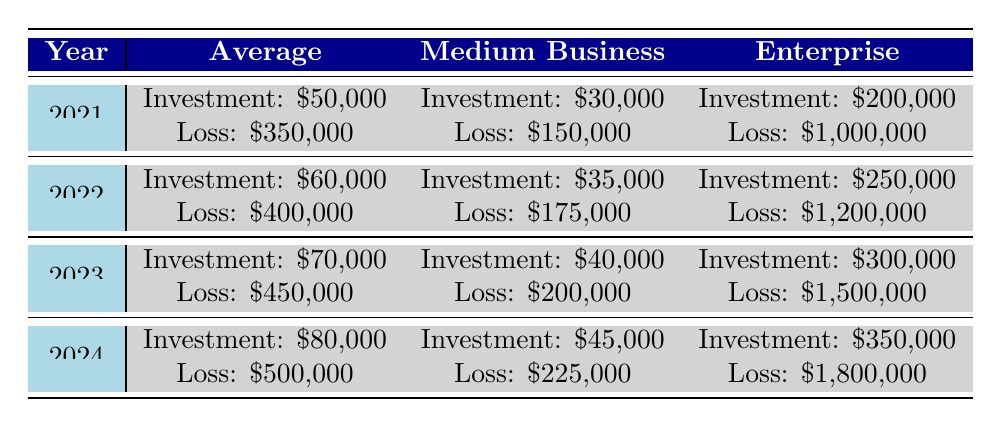What was the average security investment in 2022? Looking at the row for 2022 under the "Average" column, the average security investment listed is $60,000.
Answer: $60,000 What was the loss from breaches for medium businesses in 2021? From the row for 2021 under the "Medium Business" column, the loss from breaches is recorded as $150,000.
Answer: $150,000 How much more did enterprises invest in security in 2023 compared to 2021? The enterprise security investment in 2023 is $300,000, while in 2021 it was $200,000. The difference is $300,000 - $200,000 = $100,000.
Answer: $100,000 In which year did the average loss from breaches exceed $400,000? Checking the "Average" loss column year by year, we see that losses exceeded $400,000 starting in 2022, with the average loss being $400,000 in that year and continuing to increase in the following years.
Answer: 2022 Is the average security investment for medium businesses higher than the losses from breaches for the same category in 2024? In 2024, the average security investment for medium businesses is $45,000, and the loss from breaches is $225,000. Since $45,000 is less than $225,000, the statement is false.
Answer: No What was the percentage increase in average security investment from 2021 to 2024? The average security investment in 2021 was $50,000 and in 2024 it is $80,000. The difference is $80,000 - $50,000 = $30,000. The percentage increase is ($30,000 / $50,000) * 100 = 60%.
Answer: 60% Which year saw the highest average loss from breaches, and what was that amount? Looking at the "Average" loss column, the highest amount is in 2024, which is $500,000.
Answer: 2024, $500,000 How does the loss from breaches for enterprises in 2022 compare to medium businesses in 2023? The loss for enterprises in 2022 is $1,200,000, while for medium businesses in 2023 it is $200,000. Clearly, $1,200,000 is greater than $200,000.
Answer: Higher What is the total amount of average investments across all categories in 2024? In 2024, the average investment is $80,000, medium business is $45,000, and enterprise is $350,000. The total is $80,000 + $45,000 + $350,000 = $475,000.
Answer: $475,000 